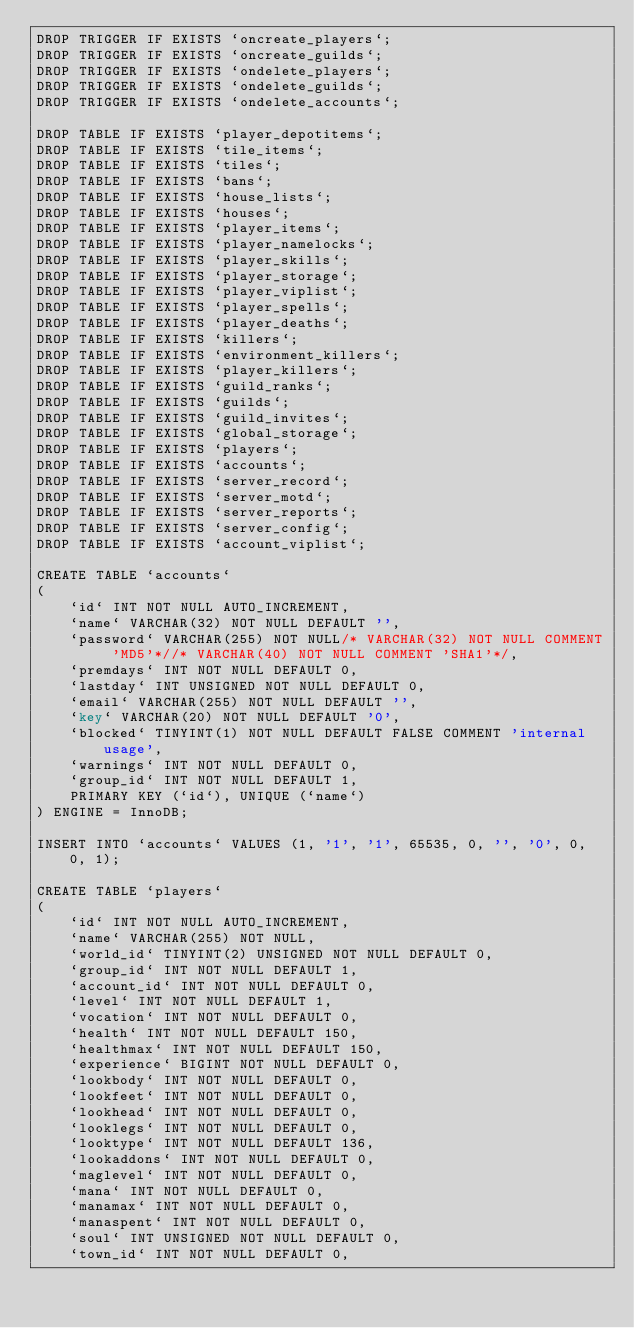<code> <loc_0><loc_0><loc_500><loc_500><_SQL_>DROP TRIGGER IF EXISTS `oncreate_players`;
DROP TRIGGER IF EXISTS `oncreate_guilds`;
DROP TRIGGER IF EXISTS `ondelete_players`;
DROP TRIGGER IF EXISTS `ondelete_guilds`;
DROP TRIGGER IF EXISTS `ondelete_accounts`;

DROP TABLE IF EXISTS `player_depotitems`;
DROP TABLE IF EXISTS `tile_items`;
DROP TABLE IF EXISTS `tiles`;
DROP TABLE IF EXISTS `bans`;
DROP TABLE IF EXISTS `house_lists`;
DROP TABLE IF EXISTS `houses`;
DROP TABLE IF EXISTS `player_items`;
DROP TABLE IF EXISTS `player_namelocks`;
DROP TABLE IF EXISTS `player_skills`;
DROP TABLE IF EXISTS `player_storage`;
DROP TABLE IF EXISTS `player_viplist`;
DROP TABLE IF EXISTS `player_spells`;
DROP TABLE IF EXISTS `player_deaths`;
DROP TABLE IF EXISTS `killers`;
DROP TABLE IF EXISTS `environment_killers`;
DROP TABLE IF EXISTS `player_killers`;
DROP TABLE IF EXISTS `guild_ranks`;
DROP TABLE IF EXISTS `guilds`;
DROP TABLE IF EXISTS `guild_invites`;
DROP TABLE IF EXISTS `global_storage`;
DROP TABLE IF EXISTS `players`;
DROP TABLE IF EXISTS `accounts`;
DROP TABLE IF EXISTS `server_record`;
DROP TABLE IF EXISTS `server_motd`;
DROP TABLE IF EXISTS `server_reports`;
DROP TABLE IF EXISTS `server_config`;
DROP TABLE IF EXISTS `account_viplist`;

CREATE TABLE `accounts`
(
	`id` INT NOT NULL AUTO_INCREMENT,
	`name` VARCHAR(32) NOT NULL DEFAULT '',
	`password` VARCHAR(255) NOT NULL/* VARCHAR(32) NOT NULL COMMENT 'MD5'*//* VARCHAR(40) NOT NULL COMMENT 'SHA1'*/,
	`premdays` INT NOT NULL DEFAULT 0,
	`lastday` INT UNSIGNED NOT NULL DEFAULT 0,
	`email` VARCHAR(255) NOT NULL DEFAULT '',
	`key` VARCHAR(20) NOT NULL DEFAULT '0',
	`blocked` TINYINT(1) NOT NULL DEFAULT FALSE COMMENT 'internal usage',
	`warnings` INT NOT NULL DEFAULT 0,
	`group_id` INT NOT NULL DEFAULT 1,
	PRIMARY KEY (`id`), UNIQUE (`name`)
) ENGINE = InnoDB;

INSERT INTO `accounts` VALUES (1, '1', '1', 65535, 0, '', '0', 0, 0, 1);

CREATE TABLE `players`
(
	`id` INT NOT NULL AUTO_INCREMENT,
	`name` VARCHAR(255) NOT NULL,
	`world_id` TINYINT(2) UNSIGNED NOT NULL DEFAULT 0,
	`group_id` INT NOT NULL DEFAULT 1,
	`account_id` INT NOT NULL DEFAULT 0,
	`level` INT NOT NULL DEFAULT 1,
	`vocation` INT NOT NULL DEFAULT 0,
	`health` INT NOT NULL DEFAULT 150,
	`healthmax` INT NOT NULL DEFAULT 150,
	`experience` BIGINT NOT NULL DEFAULT 0,
	`lookbody` INT NOT NULL DEFAULT 0,
	`lookfeet` INT NOT NULL DEFAULT 0,
	`lookhead` INT NOT NULL DEFAULT 0,
	`looklegs` INT NOT NULL DEFAULT 0,
	`looktype` INT NOT NULL DEFAULT 136,
	`lookaddons` INT NOT NULL DEFAULT 0,
	`maglevel` INT NOT NULL DEFAULT 0,
	`mana` INT NOT NULL DEFAULT 0,
	`manamax` INT NOT NULL DEFAULT 0,
	`manaspent` INT NOT NULL DEFAULT 0,
	`soul` INT UNSIGNED NOT NULL DEFAULT 0,
	`town_id` INT NOT NULL DEFAULT 0,</code> 